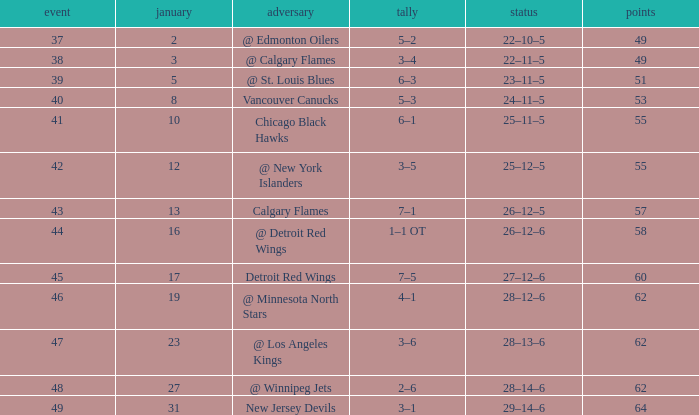How much January has a Record of 26–12–6, and Points smaller than 58? None. 